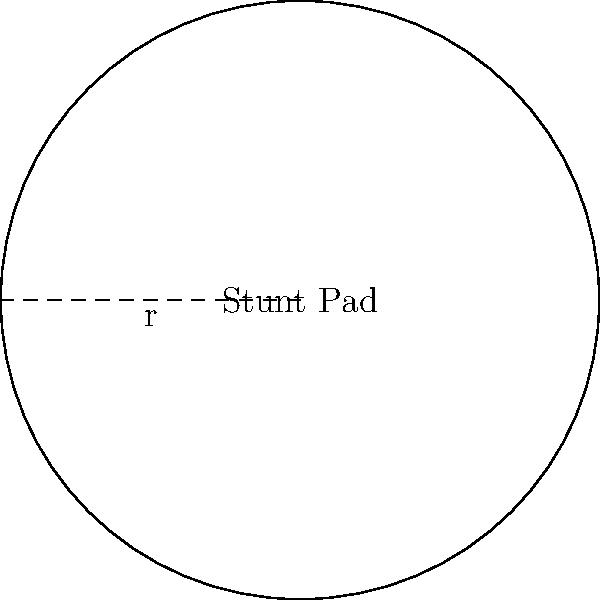For your latest action movie, you need to calculate the area of a circular stunt pad. If the radius of the pad is 15 feet, what is its total area in square feet? (Use $\pi \approx 3.14$) To find the area of a circular stunt pad, we need to use the formula for the area of a circle:

$$A = \pi r^2$$

Where:
$A$ = area of the circle
$\pi$ ≈ 3.14 (given approximation)
$r$ = radius of the circle

Given:
Radius ($r$) = 15 feet

Let's substitute these values into the formula:

$$A = \pi r^2$$
$$A = 3.14 \times 15^2$$
$$A = 3.14 \times 225$$
$$A = 706.5 \text{ square feet}$$

Therefore, the area of the circular stunt pad is approximately 706.5 square feet.
Answer: 706.5 square feet 